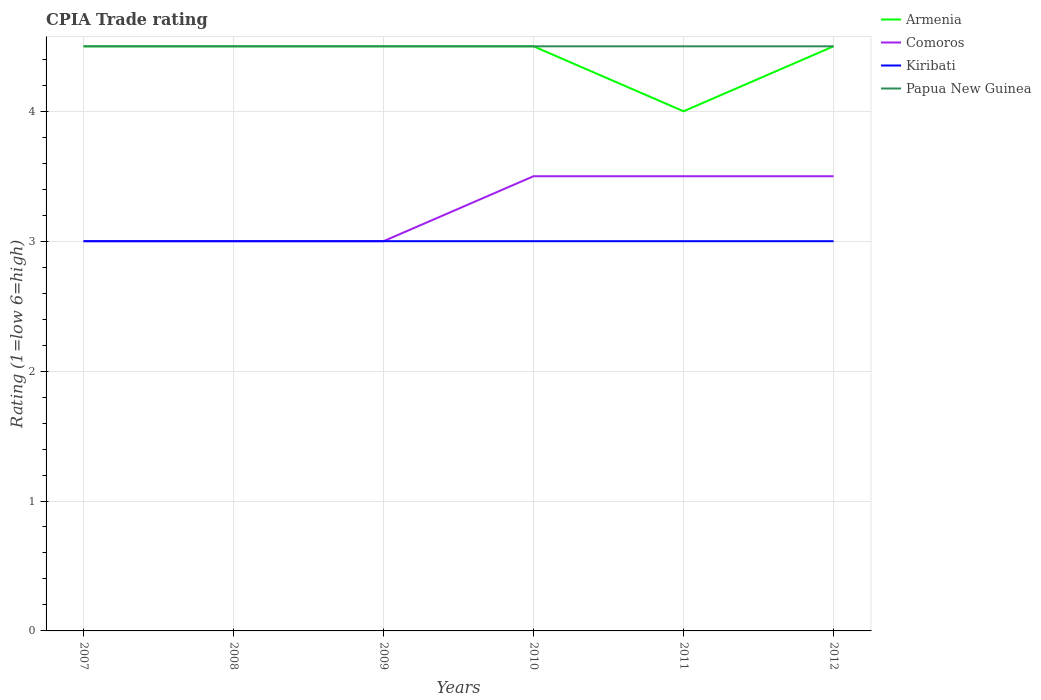How many different coloured lines are there?
Ensure brevity in your answer.  4. Does the line corresponding to Comoros intersect with the line corresponding to Kiribati?
Ensure brevity in your answer.  Yes. Is the number of lines equal to the number of legend labels?
Provide a short and direct response. Yes. Across all years, what is the maximum CPIA rating in Papua New Guinea?
Give a very brief answer. 4.5. What is the total CPIA rating in Papua New Guinea in the graph?
Your response must be concise. 0. What is the difference between the highest and the second highest CPIA rating in Kiribati?
Make the answer very short. 0. What is the difference between the highest and the lowest CPIA rating in Kiribati?
Provide a succinct answer. 0. Is the CPIA rating in Kiribati strictly greater than the CPIA rating in Comoros over the years?
Your answer should be compact. No. How many lines are there?
Ensure brevity in your answer.  4. How many years are there in the graph?
Offer a terse response. 6. Are the values on the major ticks of Y-axis written in scientific E-notation?
Offer a very short reply. No. How many legend labels are there?
Provide a succinct answer. 4. How are the legend labels stacked?
Your answer should be compact. Vertical. What is the title of the graph?
Ensure brevity in your answer.  CPIA Trade rating. Does "Algeria" appear as one of the legend labels in the graph?
Give a very brief answer. No. What is the label or title of the Y-axis?
Provide a succinct answer. Rating (1=low 6=high). What is the Rating (1=low 6=high) in Kiribati in 2008?
Provide a short and direct response. 3. What is the Rating (1=low 6=high) in Armenia in 2009?
Provide a succinct answer. 4.5. What is the Rating (1=low 6=high) in Papua New Guinea in 2009?
Ensure brevity in your answer.  4.5. What is the Rating (1=low 6=high) of Kiribati in 2010?
Keep it short and to the point. 3. What is the Rating (1=low 6=high) of Papua New Guinea in 2010?
Give a very brief answer. 4.5. What is the Rating (1=low 6=high) of Papua New Guinea in 2011?
Ensure brevity in your answer.  4.5. What is the Rating (1=low 6=high) in Kiribati in 2012?
Keep it short and to the point. 3. Across all years, what is the maximum Rating (1=low 6=high) of Armenia?
Offer a very short reply. 4.5. Across all years, what is the maximum Rating (1=low 6=high) in Kiribati?
Your response must be concise. 3. Across all years, what is the maximum Rating (1=low 6=high) in Papua New Guinea?
Your answer should be very brief. 4.5. Across all years, what is the minimum Rating (1=low 6=high) of Kiribati?
Ensure brevity in your answer.  3. Across all years, what is the minimum Rating (1=low 6=high) in Papua New Guinea?
Give a very brief answer. 4.5. What is the difference between the Rating (1=low 6=high) in Armenia in 2007 and that in 2008?
Your response must be concise. 0. What is the difference between the Rating (1=low 6=high) in Comoros in 2007 and that in 2008?
Your response must be concise. 0. What is the difference between the Rating (1=low 6=high) of Comoros in 2007 and that in 2009?
Offer a terse response. 0. What is the difference between the Rating (1=low 6=high) of Comoros in 2007 and that in 2010?
Offer a very short reply. -0.5. What is the difference between the Rating (1=low 6=high) in Kiribati in 2007 and that in 2010?
Your response must be concise. 0. What is the difference between the Rating (1=low 6=high) of Papua New Guinea in 2007 and that in 2010?
Offer a very short reply. 0. What is the difference between the Rating (1=low 6=high) in Armenia in 2007 and that in 2011?
Your answer should be compact. 0.5. What is the difference between the Rating (1=low 6=high) of Comoros in 2007 and that in 2011?
Ensure brevity in your answer.  -0.5. What is the difference between the Rating (1=low 6=high) in Kiribati in 2007 and that in 2011?
Your response must be concise. 0. What is the difference between the Rating (1=low 6=high) in Papua New Guinea in 2007 and that in 2011?
Your answer should be compact. 0. What is the difference between the Rating (1=low 6=high) in Comoros in 2007 and that in 2012?
Provide a short and direct response. -0.5. What is the difference between the Rating (1=low 6=high) in Kiribati in 2007 and that in 2012?
Offer a very short reply. 0. What is the difference between the Rating (1=low 6=high) of Kiribati in 2008 and that in 2009?
Offer a terse response. 0. What is the difference between the Rating (1=low 6=high) of Armenia in 2008 and that in 2010?
Your response must be concise. 0. What is the difference between the Rating (1=low 6=high) in Papua New Guinea in 2008 and that in 2010?
Offer a terse response. 0. What is the difference between the Rating (1=low 6=high) in Comoros in 2008 and that in 2011?
Give a very brief answer. -0.5. What is the difference between the Rating (1=low 6=high) in Kiribati in 2008 and that in 2011?
Your response must be concise. 0. What is the difference between the Rating (1=low 6=high) of Papua New Guinea in 2008 and that in 2011?
Offer a very short reply. 0. What is the difference between the Rating (1=low 6=high) of Armenia in 2008 and that in 2012?
Your answer should be compact. 0. What is the difference between the Rating (1=low 6=high) of Comoros in 2008 and that in 2012?
Your answer should be very brief. -0.5. What is the difference between the Rating (1=low 6=high) of Papua New Guinea in 2008 and that in 2012?
Provide a short and direct response. 0. What is the difference between the Rating (1=low 6=high) of Kiribati in 2009 and that in 2010?
Provide a succinct answer. 0. What is the difference between the Rating (1=low 6=high) in Papua New Guinea in 2009 and that in 2010?
Your answer should be very brief. 0. What is the difference between the Rating (1=low 6=high) in Kiribati in 2009 and that in 2011?
Give a very brief answer. 0. What is the difference between the Rating (1=low 6=high) of Papua New Guinea in 2009 and that in 2012?
Your answer should be very brief. 0. What is the difference between the Rating (1=low 6=high) in Kiribati in 2010 and that in 2011?
Provide a succinct answer. 0. What is the difference between the Rating (1=low 6=high) of Comoros in 2010 and that in 2012?
Keep it short and to the point. 0. What is the difference between the Rating (1=low 6=high) of Comoros in 2011 and that in 2012?
Your answer should be compact. 0. What is the difference between the Rating (1=low 6=high) of Kiribati in 2011 and that in 2012?
Your answer should be very brief. 0. What is the difference between the Rating (1=low 6=high) in Armenia in 2007 and the Rating (1=low 6=high) in Comoros in 2008?
Provide a short and direct response. 1.5. What is the difference between the Rating (1=low 6=high) of Armenia in 2007 and the Rating (1=low 6=high) of Kiribati in 2009?
Your answer should be compact. 1.5. What is the difference between the Rating (1=low 6=high) in Armenia in 2007 and the Rating (1=low 6=high) in Papua New Guinea in 2009?
Give a very brief answer. 0. What is the difference between the Rating (1=low 6=high) in Comoros in 2007 and the Rating (1=low 6=high) in Kiribati in 2009?
Your answer should be very brief. 0. What is the difference between the Rating (1=low 6=high) in Armenia in 2007 and the Rating (1=low 6=high) in Comoros in 2010?
Offer a terse response. 1. What is the difference between the Rating (1=low 6=high) of Comoros in 2007 and the Rating (1=low 6=high) of Papua New Guinea in 2010?
Provide a short and direct response. -1.5. What is the difference between the Rating (1=low 6=high) in Kiribati in 2007 and the Rating (1=low 6=high) in Papua New Guinea in 2010?
Offer a terse response. -1.5. What is the difference between the Rating (1=low 6=high) of Armenia in 2007 and the Rating (1=low 6=high) of Kiribati in 2011?
Ensure brevity in your answer.  1.5. What is the difference between the Rating (1=low 6=high) in Armenia in 2007 and the Rating (1=low 6=high) in Comoros in 2012?
Your answer should be very brief. 1. What is the difference between the Rating (1=low 6=high) of Comoros in 2007 and the Rating (1=low 6=high) of Kiribati in 2012?
Your response must be concise. 0. What is the difference between the Rating (1=low 6=high) of Armenia in 2008 and the Rating (1=low 6=high) of Comoros in 2009?
Offer a terse response. 1.5. What is the difference between the Rating (1=low 6=high) of Armenia in 2008 and the Rating (1=low 6=high) of Kiribati in 2009?
Your response must be concise. 1.5. What is the difference between the Rating (1=low 6=high) of Comoros in 2008 and the Rating (1=low 6=high) of Papua New Guinea in 2009?
Offer a terse response. -1.5. What is the difference between the Rating (1=low 6=high) in Armenia in 2008 and the Rating (1=low 6=high) in Kiribati in 2010?
Make the answer very short. 1.5. What is the difference between the Rating (1=low 6=high) of Armenia in 2008 and the Rating (1=low 6=high) of Papua New Guinea in 2010?
Provide a short and direct response. 0. What is the difference between the Rating (1=low 6=high) of Comoros in 2008 and the Rating (1=low 6=high) of Kiribati in 2010?
Make the answer very short. 0. What is the difference between the Rating (1=low 6=high) of Comoros in 2008 and the Rating (1=low 6=high) of Papua New Guinea in 2010?
Offer a terse response. -1.5. What is the difference between the Rating (1=low 6=high) of Kiribati in 2008 and the Rating (1=low 6=high) of Papua New Guinea in 2010?
Keep it short and to the point. -1.5. What is the difference between the Rating (1=low 6=high) of Comoros in 2008 and the Rating (1=low 6=high) of Kiribati in 2011?
Provide a succinct answer. 0. What is the difference between the Rating (1=low 6=high) in Comoros in 2008 and the Rating (1=low 6=high) in Papua New Guinea in 2011?
Your answer should be very brief. -1.5. What is the difference between the Rating (1=low 6=high) of Armenia in 2008 and the Rating (1=low 6=high) of Comoros in 2012?
Provide a short and direct response. 1. What is the difference between the Rating (1=low 6=high) of Armenia in 2008 and the Rating (1=low 6=high) of Papua New Guinea in 2012?
Ensure brevity in your answer.  0. What is the difference between the Rating (1=low 6=high) of Kiribati in 2008 and the Rating (1=low 6=high) of Papua New Guinea in 2012?
Ensure brevity in your answer.  -1.5. What is the difference between the Rating (1=low 6=high) of Comoros in 2009 and the Rating (1=low 6=high) of Kiribati in 2010?
Your response must be concise. 0. What is the difference between the Rating (1=low 6=high) in Comoros in 2009 and the Rating (1=low 6=high) in Papua New Guinea in 2010?
Provide a short and direct response. -1.5. What is the difference between the Rating (1=low 6=high) of Kiribati in 2009 and the Rating (1=low 6=high) of Papua New Guinea in 2010?
Your answer should be very brief. -1.5. What is the difference between the Rating (1=low 6=high) in Kiribati in 2009 and the Rating (1=low 6=high) in Papua New Guinea in 2011?
Keep it short and to the point. -1.5. What is the difference between the Rating (1=low 6=high) of Armenia in 2009 and the Rating (1=low 6=high) of Comoros in 2012?
Your answer should be compact. 1. What is the difference between the Rating (1=low 6=high) in Kiribati in 2009 and the Rating (1=low 6=high) in Papua New Guinea in 2012?
Make the answer very short. -1.5. What is the difference between the Rating (1=low 6=high) of Armenia in 2010 and the Rating (1=low 6=high) of Kiribati in 2011?
Provide a succinct answer. 1.5. What is the difference between the Rating (1=low 6=high) of Armenia in 2010 and the Rating (1=low 6=high) of Papua New Guinea in 2011?
Give a very brief answer. 0. What is the difference between the Rating (1=low 6=high) in Kiribati in 2010 and the Rating (1=low 6=high) in Papua New Guinea in 2011?
Your response must be concise. -1.5. What is the difference between the Rating (1=low 6=high) of Armenia in 2010 and the Rating (1=low 6=high) of Comoros in 2012?
Offer a very short reply. 1. What is the difference between the Rating (1=low 6=high) of Comoros in 2010 and the Rating (1=low 6=high) of Kiribati in 2012?
Offer a terse response. 0.5. What is the difference between the Rating (1=low 6=high) in Kiribati in 2010 and the Rating (1=low 6=high) in Papua New Guinea in 2012?
Give a very brief answer. -1.5. What is the difference between the Rating (1=low 6=high) in Armenia in 2011 and the Rating (1=low 6=high) in Comoros in 2012?
Keep it short and to the point. 0.5. What is the difference between the Rating (1=low 6=high) in Armenia in 2011 and the Rating (1=low 6=high) in Kiribati in 2012?
Your answer should be compact. 1. What is the difference between the Rating (1=low 6=high) of Kiribati in 2011 and the Rating (1=low 6=high) of Papua New Guinea in 2012?
Your answer should be compact. -1.5. What is the average Rating (1=low 6=high) of Armenia per year?
Provide a short and direct response. 4.42. What is the average Rating (1=low 6=high) in Kiribati per year?
Make the answer very short. 3. What is the average Rating (1=low 6=high) in Papua New Guinea per year?
Offer a very short reply. 4.5. In the year 2007, what is the difference between the Rating (1=low 6=high) in Armenia and Rating (1=low 6=high) in Comoros?
Ensure brevity in your answer.  1.5. In the year 2007, what is the difference between the Rating (1=low 6=high) of Armenia and Rating (1=low 6=high) of Kiribati?
Ensure brevity in your answer.  1.5. In the year 2007, what is the difference between the Rating (1=low 6=high) of Comoros and Rating (1=low 6=high) of Kiribati?
Make the answer very short. 0. In the year 2007, what is the difference between the Rating (1=low 6=high) in Comoros and Rating (1=low 6=high) in Papua New Guinea?
Give a very brief answer. -1.5. In the year 2008, what is the difference between the Rating (1=low 6=high) in Armenia and Rating (1=low 6=high) in Kiribati?
Make the answer very short. 1.5. In the year 2008, what is the difference between the Rating (1=low 6=high) in Armenia and Rating (1=low 6=high) in Papua New Guinea?
Provide a succinct answer. 0. In the year 2008, what is the difference between the Rating (1=low 6=high) of Comoros and Rating (1=low 6=high) of Papua New Guinea?
Offer a terse response. -1.5. In the year 2008, what is the difference between the Rating (1=low 6=high) in Kiribati and Rating (1=low 6=high) in Papua New Guinea?
Make the answer very short. -1.5. In the year 2009, what is the difference between the Rating (1=low 6=high) in Armenia and Rating (1=low 6=high) in Kiribati?
Give a very brief answer. 1.5. In the year 2009, what is the difference between the Rating (1=low 6=high) in Kiribati and Rating (1=low 6=high) in Papua New Guinea?
Provide a succinct answer. -1.5. In the year 2010, what is the difference between the Rating (1=low 6=high) of Armenia and Rating (1=low 6=high) of Comoros?
Your answer should be compact. 1. In the year 2010, what is the difference between the Rating (1=low 6=high) of Armenia and Rating (1=low 6=high) of Papua New Guinea?
Give a very brief answer. 0. In the year 2010, what is the difference between the Rating (1=low 6=high) in Comoros and Rating (1=low 6=high) in Kiribati?
Give a very brief answer. 0.5. In the year 2011, what is the difference between the Rating (1=low 6=high) in Armenia and Rating (1=low 6=high) in Comoros?
Your response must be concise. 0.5. In the year 2011, what is the difference between the Rating (1=low 6=high) in Armenia and Rating (1=low 6=high) in Kiribati?
Make the answer very short. 1. In the year 2011, what is the difference between the Rating (1=low 6=high) of Armenia and Rating (1=low 6=high) of Papua New Guinea?
Your response must be concise. -0.5. In the year 2011, what is the difference between the Rating (1=low 6=high) of Comoros and Rating (1=low 6=high) of Papua New Guinea?
Your answer should be compact. -1. In the year 2012, what is the difference between the Rating (1=low 6=high) of Armenia and Rating (1=low 6=high) of Papua New Guinea?
Your response must be concise. 0. What is the ratio of the Rating (1=low 6=high) of Armenia in 2007 to that in 2008?
Provide a succinct answer. 1. What is the ratio of the Rating (1=low 6=high) of Comoros in 2007 to that in 2008?
Your answer should be very brief. 1. What is the ratio of the Rating (1=low 6=high) of Kiribati in 2007 to that in 2009?
Ensure brevity in your answer.  1. What is the ratio of the Rating (1=low 6=high) in Papua New Guinea in 2007 to that in 2011?
Your answer should be compact. 1. What is the ratio of the Rating (1=low 6=high) in Comoros in 2007 to that in 2012?
Keep it short and to the point. 0.86. What is the ratio of the Rating (1=low 6=high) in Armenia in 2008 to that in 2009?
Make the answer very short. 1. What is the ratio of the Rating (1=low 6=high) in Papua New Guinea in 2008 to that in 2009?
Provide a short and direct response. 1. What is the ratio of the Rating (1=low 6=high) in Armenia in 2008 to that in 2010?
Give a very brief answer. 1. What is the ratio of the Rating (1=low 6=high) in Comoros in 2008 to that in 2010?
Keep it short and to the point. 0.86. What is the ratio of the Rating (1=low 6=high) of Kiribati in 2008 to that in 2010?
Keep it short and to the point. 1. What is the ratio of the Rating (1=low 6=high) of Papua New Guinea in 2008 to that in 2010?
Your response must be concise. 1. What is the ratio of the Rating (1=low 6=high) in Armenia in 2008 to that in 2011?
Your response must be concise. 1.12. What is the ratio of the Rating (1=low 6=high) in Comoros in 2008 to that in 2011?
Give a very brief answer. 0.86. What is the ratio of the Rating (1=low 6=high) of Papua New Guinea in 2008 to that in 2011?
Your answer should be very brief. 1. What is the ratio of the Rating (1=low 6=high) in Kiribati in 2008 to that in 2012?
Keep it short and to the point. 1. What is the ratio of the Rating (1=low 6=high) of Kiribati in 2009 to that in 2010?
Keep it short and to the point. 1. What is the ratio of the Rating (1=low 6=high) in Papua New Guinea in 2009 to that in 2010?
Give a very brief answer. 1. What is the ratio of the Rating (1=low 6=high) of Armenia in 2009 to that in 2011?
Offer a terse response. 1.12. What is the ratio of the Rating (1=low 6=high) of Kiribati in 2009 to that in 2011?
Ensure brevity in your answer.  1. What is the ratio of the Rating (1=low 6=high) in Papua New Guinea in 2009 to that in 2011?
Provide a succinct answer. 1. What is the ratio of the Rating (1=low 6=high) in Armenia in 2009 to that in 2012?
Offer a terse response. 1. What is the ratio of the Rating (1=low 6=high) in Comoros in 2009 to that in 2012?
Your response must be concise. 0.86. What is the ratio of the Rating (1=low 6=high) of Papua New Guinea in 2009 to that in 2012?
Your response must be concise. 1. What is the ratio of the Rating (1=low 6=high) in Armenia in 2010 to that in 2012?
Your answer should be very brief. 1. What is the ratio of the Rating (1=low 6=high) in Kiribati in 2010 to that in 2012?
Give a very brief answer. 1. What is the ratio of the Rating (1=low 6=high) of Comoros in 2011 to that in 2012?
Make the answer very short. 1. What is the ratio of the Rating (1=low 6=high) of Kiribati in 2011 to that in 2012?
Your answer should be very brief. 1. What is the difference between the highest and the second highest Rating (1=low 6=high) of Armenia?
Give a very brief answer. 0. What is the difference between the highest and the second highest Rating (1=low 6=high) in Papua New Guinea?
Your response must be concise. 0. What is the difference between the highest and the lowest Rating (1=low 6=high) of Kiribati?
Your answer should be very brief. 0. What is the difference between the highest and the lowest Rating (1=low 6=high) in Papua New Guinea?
Give a very brief answer. 0. 